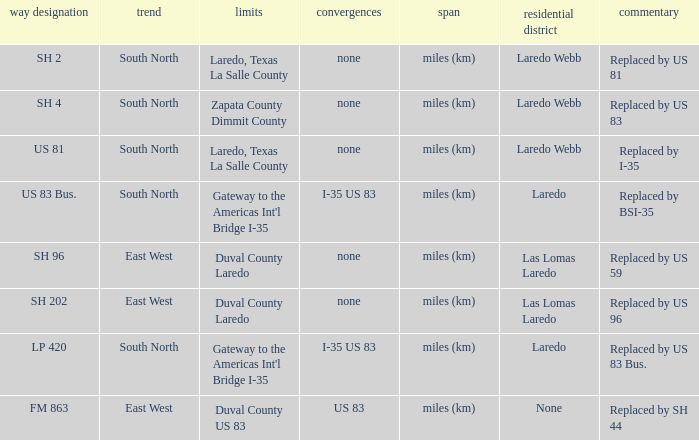Which junctions have "replaced by bsi-35" listed in their remarks section? I-35 US 83. 